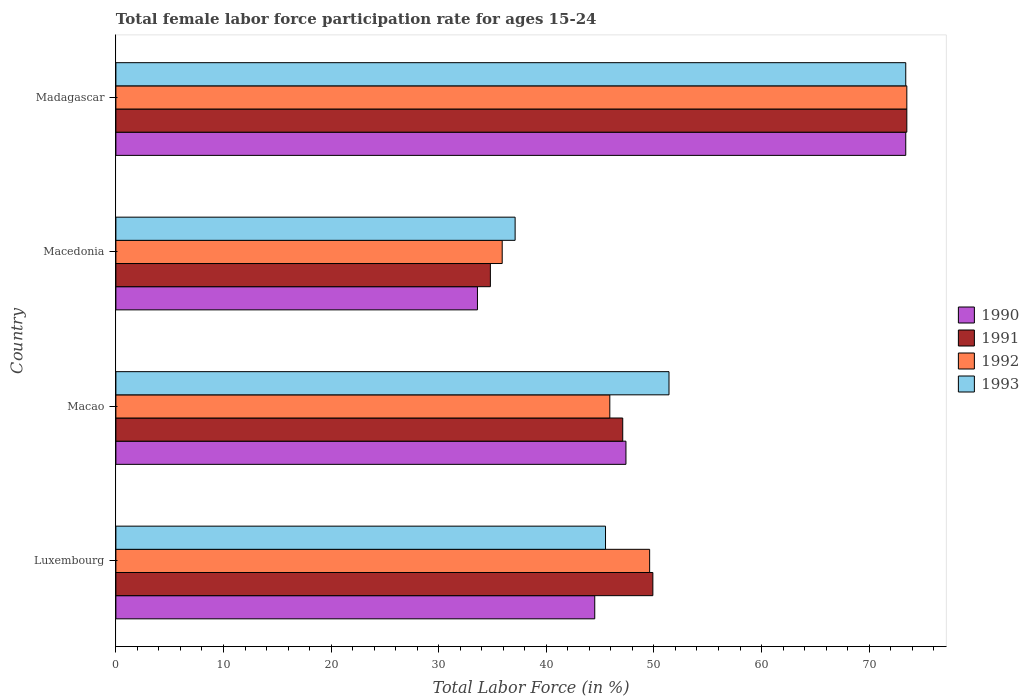How many different coloured bars are there?
Ensure brevity in your answer.  4. How many groups of bars are there?
Offer a terse response. 4. How many bars are there on the 1st tick from the top?
Your answer should be very brief. 4. What is the label of the 4th group of bars from the top?
Make the answer very short. Luxembourg. What is the female labor force participation rate in 1993 in Macedonia?
Your answer should be very brief. 37.1. Across all countries, what is the maximum female labor force participation rate in 1992?
Give a very brief answer. 73.5. Across all countries, what is the minimum female labor force participation rate in 1990?
Offer a terse response. 33.6. In which country was the female labor force participation rate in 1992 maximum?
Ensure brevity in your answer.  Madagascar. In which country was the female labor force participation rate in 1992 minimum?
Provide a succinct answer. Macedonia. What is the total female labor force participation rate in 1993 in the graph?
Your answer should be very brief. 207.4. What is the difference between the female labor force participation rate in 1993 in Macedonia and that in Madagascar?
Your answer should be compact. -36.3. What is the difference between the female labor force participation rate in 1993 in Macao and the female labor force participation rate in 1990 in Macedonia?
Ensure brevity in your answer.  17.8. What is the average female labor force participation rate in 1993 per country?
Offer a terse response. 51.85. What is the difference between the female labor force participation rate in 1991 and female labor force participation rate in 1990 in Madagascar?
Ensure brevity in your answer.  0.1. In how many countries, is the female labor force participation rate in 1993 greater than 14 %?
Offer a terse response. 4. What is the ratio of the female labor force participation rate in 1990 in Luxembourg to that in Macao?
Offer a terse response. 0.94. Is the female labor force participation rate in 1991 in Luxembourg less than that in Macao?
Provide a succinct answer. No. Is the difference between the female labor force participation rate in 1991 in Luxembourg and Madagascar greater than the difference between the female labor force participation rate in 1990 in Luxembourg and Madagascar?
Offer a very short reply. Yes. What is the difference between the highest and the second highest female labor force participation rate in 1992?
Ensure brevity in your answer.  23.9. What is the difference between the highest and the lowest female labor force participation rate in 1992?
Your answer should be compact. 37.6. In how many countries, is the female labor force participation rate in 1993 greater than the average female labor force participation rate in 1993 taken over all countries?
Provide a succinct answer. 1. Is the sum of the female labor force participation rate in 1990 in Macedonia and Madagascar greater than the maximum female labor force participation rate in 1991 across all countries?
Your response must be concise. Yes. Is it the case that in every country, the sum of the female labor force participation rate in 1990 and female labor force participation rate in 1991 is greater than the sum of female labor force participation rate in 1993 and female labor force participation rate in 1992?
Your response must be concise. No. What does the 4th bar from the top in Luxembourg represents?
Your response must be concise. 1990. What does the 1st bar from the bottom in Macedonia represents?
Your answer should be compact. 1990. How many bars are there?
Provide a succinct answer. 16. How many countries are there in the graph?
Your answer should be compact. 4. Does the graph contain any zero values?
Ensure brevity in your answer.  No. Does the graph contain grids?
Keep it short and to the point. No. What is the title of the graph?
Offer a very short reply. Total female labor force participation rate for ages 15-24. Does "1966" appear as one of the legend labels in the graph?
Keep it short and to the point. No. What is the label or title of the X-axis?
Your response must be concise. Total Labor Force (in %). What is the Total Labor Force (in %) in 1990 in Luxembourg?
Give a very brief answer. 44.5. What is the Total Labor Force (in %) of 1991 in Luxembourg?
Offer a very short reply. 49.9. What is the Total Labor Force (in %) in 1992 in Luxembourg?
Your answer should be compact. 49.6. What is the Total Labor Force (in %) of 1993 in Luxembourg?
Your response must be concise. 45.5. What is the Total Labor Force (in %) of 1990 in Macao?
Your response must be concise. 47.4. What is the Total Labor Force (in %) in 1991 in Macao?
Give a very brief answer. 47.1. What is the Total Labor Force (in %) of 1992 in Macao?
Offer a terse response. 45.9. What is the Total Labor Force (in %) of 1993 in Macao?
Make the answer very short. 51.4. What is the Total Labor Force (in %) of 1990 in Macedonia?
Keep it short and to the point. 33.6. What is the Total Labor Force (in %) in 1991 in Macedonia?
Make the answer very short. 34.8. What is the Total Labor Force (in %) in 1992 in Macedonia?
Keep it short and to the point. 35.9. What is the Total Labor Force (in %) in 1993 in Macedonia?
Your answer should be compact. 37.1. What is the Total Labor Force (in %) of 1990 in Madagascar?
Ensure brevity in your answer.  73.4. What is the Total Labor Force (in %) in 1991 in Madagascar?
Provide a succinct answer. 73.5. What is the Total Labor Force (in %) in 1992 in Madagascar?
Offer a very short reply. 73.5. What is the Total Labor Force (in %) in 1993 in Madagascar?
Your response must be concise. 73.4. Across all countries, what is the maximum Total Labor Force (in %) in 1990?
Your response must be concise. 73.4. Across all countries, what is the maximum Total Labor Force (in %) in 1991?
Offer a very short reply. 73.5. Across all countries, what is the maximum Total Labor Force (in %) of 1992?
Provide a succinct answer. 73.5. Across all countries, what is the maximum Total Labor Force (in %) in 1993?
Ensure brevity in your answer.  73.4. Across all countries, what is the minimum Total Labor Force (in %) of 1990?
Offer a very short reply. 33.6. Across all countries, what is the minimum Total Labor Force (in %) in 1991?
Your answer should be compact. 34.8. Across all countries, what is the minimum Total Labor Force (in %) in 1992?
Keep it short and to the point. 35.9. Across all countries, what is the minimum Total Labor Force (in %) of 1993?
Ensure brevity in your answer.  37.1. What is the total Total Labor Force (in %) in 1990 in the graph?
Give a very brief answer. 198.9. What is the total Total Labor Force (in %) of 1991 in the graph?
Your answer should be very brief. 205.3. What is the total Total Labor Force (in %) in 1992 in the graph?
Make the answer very short. 204.9. What is the total Total Labor Force (in %) of 1993 in the graph?
Your answer should be very brief. 207.4. What is the difference between the Total Labor Force (in %) of 1991 in Luxembourg and that in Macao?
Provide a short and direct response. 2.8. What is the difference between the Total Labor Force (in %) of 1992 in Luxembourg and that in Macao?
Provide a succinct answer. 3.7. What is the difference between the Total Labor Force (in %) of 1993 in Luxembourg and that in Macao?
Give a very brief answer. -5.9. What is the difference between the Total Labor Force (in %) of 1991 in Luxembourg and that in Macedonia?
Make the answer very short. 15.1. What is the difference between the Total Labor Force (in %) in 1992 in Luxembourg and that in Macedonia?
Give a very brief answer. 13.7. What is the difference between the Total Labor Force (in %) of 1993 in Luxembourg and that in Macedonia?
Keep it short and to the point. 8.4. What is the difference between the Total Labor Force (in %) of 1990 in Luxembourg and that in Madagascar?
Your response must be concise. -28.9. What is the difference between the Total Labor Force (in %) in 1991 in Luxembourg and that in Madagascar?
Offer a very short reply. -23.6. What is the difference between the Total Labor Force (in %) in 1992 in Luxembourg and that in Madagascar?
Provide a short and direct response. -23.9. What is the difference between the Total Labor Force (in %) of 1993 in Luxembourg and that in Madagascar?
Your answer should be compact. -27.9. What is the difference between the Total Labor Force (in %) in 1990 in Macao and that in Macedonia?
Your answer should be very brief. 13.8. What is the difference between the Total Labor Force (in %) in 1992 in Macao and that in Macedonia?
Your response must be concise. 10. What is the difference between the Total Labor Force (in %) of 1990 in Macao and that in Madagascar?
Ensure brevity in your answer.  -26. What is the difference between the Total Labor Force (in %) of 1991 in Macao and that in Madagascar?
Give a very brief answer. -26.4. What is the difference between the Total Labor Force (in %) in 1992 in Macao and that in Madagascar?
Your answer should be compact. -27.6. What is the difference between the Total Labor Force (in %) in 1990 in Macedonia and that in Madagascar?
Keep it short and to the point. -39.8. What is the difference between the Total Labor Force (in %) of 1991 in Macedonia and that in Madagascar?
Ensure brevity in your answer.  -38.7. What is the difference between the Total Labor Force (in %) of 1992 in Macedonia and that in Madagascar?
Make the answer very short. -37.6. What is the difference between the Total Labor Force (in %) of 1993 in Macedonia and that in Madagascar?
Provide a succinct answer. -36.3. What is the difference between the Total Labor Force (in %) in 1990 in Luxembourg and the Total Labor Force (in %) in 1991 in Macao?
Your answer should be compact. -2.6. What is the difference between the Total Labor Force (in %) of 1990 in Luxembourg and the Total Labor Force (in %) of 1993 in Macao?
Make the answer very short. -6.9. What is the difference between the Total Labor Force (in %) in 1992 in Luxembourg and the Total Labor Force (in %) in 1993 in Macao?
Keep it short and to the point. -1.8. What is the difference between the Total Labor Force (in %) of 1990 in Luxembourg and the Total Labor Force (in %) of 1992 in Macedonia?
Keep it short and to the point. 8.6. What is the difference between the Total Labor Force (in %) in 1990 in Luxembourg and the Total Labor Force (in %) in 1993 in Macedonia?
Offer a very short reply. 7.4. What is the difference between the Total Labor Force (in %) in 1992 in Luxembourg and the Total Labor Force (in %) in 1993 in Macedonia?
Make the answer very short. 12.5. What is the difference between the Total Labor Force (in %) of 1990 in Luxembourg and the Total Labor Force (in %) of 1993 in Madagascar?
Make the answer very short. -28.9. What is the difference between the Total Labor Force (in %) of 1991 in Luxembourg and the Total Labor Force (in %) of 1992 in Madagascar?
Offer a terse response. -23.6. What is the difference between the Total Labor Force (in %) of 1991 in Luxembourg and the Total Labor Force (in %) of 1993 in Madagascar?
Offer a terse response. -23.5. What is the difference between the Total Labor Force (in %) of 1992 in Luxembourg and the Total Labor Force (in %) of 1993 in Madagascar?
Your answer should be compact. -23.8. What is the difference between the Total Labor Force (in %) of 1990 in Macao and the Total Labor Force (in %) of 1992 in Macedonia?
Provide a short and direct response. 11.5. What is the difference between the Total Labor Force (in %) in 1990 in Macao and the Total Labor Force (in %) in 1993 in Macedonia?
Your answer should be compact. 10.3. What is the difference between the Total Labor Force (in %) of 1991 in Macao and the Total Labor Force (in %) of 1992 in Macedonia?
Keep it short and to the point. 11.2. What is the difference between the Total Labor Force (in %) in 1992 in Macao and the Total Labor Force (in %) in 1993 in Macedonia?
Give a very brief answer. 8.8. What is the difference between the Total Labor Force (in %) of 1990 in Macao and the Total Labor Force (in %) of 1991 in Madagascar?
Provide a short and direct response. -26.1. What is the difference between the Total Labor Force (in %) of 1990 in Macao and the Total Labor Force (in %) of 1992 in Madagascar?
Provide a short and direct response. -26.1. What is the difference between the Total Labor Force (in %) in 1990 in Macao and the Total Labor Force (in %) in 1993 in Madagascar?
Offer a terse response. -26. What is the difference between the Total Labor Force (in %) in 1991 in Macao and the Total Labor Force (in %) in 1992 in Madagascar?
Your answer should be compact. -26.4. What is the difference between the Total Labor Force (in %) in 1991 in Macao and the Total Labor Force (in %) in 1993 in Madagascar?
Offer a very short reply. -26.3. What is the difference between the Total Labor Force (in %) in 1992 in Macao and the Total Labor Force (in %) in 1993 in Madagascar?
Keep it short and to the point. -27.5. What is the difference between the Total Labor Force (in %) in 1990 in Macedonia and the Total Labor Force (in %) in 1991 in Madagascar?
Your answer should be compact. -39.9. What is the difference between the Total Labor Force (in %) in 1990 in Macedonia and the Total Labor Force (in %) in 1992 in Madagascar?
Your answer should be very brief. -39.9. What is the difference between the Total Labor Force (in %) of 1990 in Macedonia and the Total Labor Force (in %) of 1993 in Madagascar?
Give a very brief answer. -39.8. What is the difference between the Total Labor Force (in %) of 1991 in Macedonia and the Total Labor Force (in %) of 1992 in Madagascar?
Your answer should be compact. -38.7. What is the difference between the Total Labor Force (in %) in 1991 in Macedonia and the Total Labor Force (in %) in 1993 in Madagascar?
Keep it short and to the point. -38.6. What is the difference between the Total Labor Force (in %) in 1992 in Macedonia and the Total Labor Force (in %) in 1993 in Madagascar?
Offer a terse response. -37.5. What is the average Total Labor Force (in %) in 1990 per country?
Your answer should be very brief. 49.73. What is the average Total Labor Force (in %) of 1991 per country?
Provide a succinct answer. 51.33. What is the average Total Labor Force (in %) of 1992 per country?
Provide a short and direct response. 51.23. What is the average Total Labor Force (in %) of 1993 per country?
Offer a very short reply. 51.85. What is the difference between the Total Labor Force (in %) of 1990 and Total Labor Force (in %) of 1992 in Luxembourg?
Make the answer very short. -5.1. What is the difference between the Total Labor Force (in %) of 1990 and Total Labor Force (in %) of 1993 in Luxembourg?
Offer a terse response. -1. What is the difference between the Total Labor Force (in %) in 1991 and Total Labor Force (in %) in 1992 in Luxembourg?
Make the answer very short. 0.3. What is the difference between the Total Labor Force (in %) in 1990 and Total Labor Force (in %) in 1992 in Macao?
Your response must be concise. 1.5. What is the difference between the Total Labor Force (in %) of 1991 and Total Labor Force (in %) of 1992 in Macao?
Keep it short and to the point. 1.2. What is the difference between the Total Labor Force (in %) in 1991 and Total Labor Force (in %) in 1993 in Macao?
Give a very brief answer. -4.3. What is the difference between the Total Labor Force (in %) in 1990 and Total Labor Force (in %) in 1991 in Macedonia?
Give a very brief answer. -1.2. What is the difference between the Total Labor Force (in %) in 1990 and Total Labor Force (in %) in 1993 in Macedonia?
Offer a terse response. -3.5. What is the difference between the Total Labor Force (in %) of 1991 and Total Labor Force (in %) of 1992 in Macedonia?
Ensure brevity in your answer.  -1.1. What is the difference between the Total Labor Force (in %) in 1990 and Total Labor Force (in %) in 1993 in Madagascar?
Keep it short and to the point. 0. What is the difference between the Total Labor Force (in %) of 1991 and Total Labor Force (in %) of 1992 in Madagascar?
Ensure brevity in your answer.  0. What is the difference between the Total Labor Force (in %) of 1992 and Total Labor Force (in %) of 1993 in Madagascar?
Offer a terse response. 0.1. What is the ratio of the Total Labor Force (in %) of 1990 in Luxembourg to that in Macao?
Give a very brief answer. 0.94. What is the ratio of the Total Labor Force (in %) of 1991 in Luxembourg to that in Macao?
Provide a succinct answer. 1.06. What is the ratio of the Total Labor Force (in %) of 1992 in Luxembourg to that in Macao?
Ensure brevity in your answer.  1.08. What is the ratio of the Total Labor Force (in %) in 1993 in Luxembourg to that in Macao?
Offer a terse response. 0.89. What is the ratio of the Total Labor Force (in %) of 1990 in Luxembourg to that in Macedonia?
Ensure brevity in your answer.  1.32. What is the ratio of the Total Labor Force (in %) in 1991 in Luxembourg to that in Macedonia?
Keep it short and to the point. 1.43. What is the ratio of the Total Labor Force (in %) of 1992 in Luxembourg to that in Macedonia?
Your answer should be compact. 1.38. What is the ratio of the Total Labor Force (in %) in 1993 in Luxembourg to that in Macedonia?
Give a very brief answer. 1.23. What is the ratio of the Total Labor Force (in %) of 1990 in Luxembourg to that in Madagascar?
Provide a short and direct response. 0.61. What is the ratio of the Total Labor Force (in %) in 1991 in Luxembourg to that in Madagascar?
Keep it short and to the point. 0.68. What is the ratio of the Total Labor Force (in %) in 1992 in Luxembourg to that in Madagascar?
Your answer should be compact. 0.67. What is the ratio of the Total Labor Force (in %) in 1993 in Luxembourg to that in Madagascar?
Make the answer very short. 0.62. What is the ratio of the Total Labor Force (in %) in 1990 in Macao to that in Macedonia?
Make the answer very short. 1.41. What is the ratio of the Total Labor Force (in %) of 1991 in Macao to that in Macedonia?
Provide a short and direct response. 1.35. What is the ratio of the Total Labor Force (in %) in 1992 in Macao to that in Macedonia?
Your answer should be very brief. 1.28. What is the ratio of the Total Labor Force (in %) in 1993 in Macao to that in Macedonia?
Give a very brief answer. 1.39. What is the ratio of the Total Labor Force (in %) in 1990 in Macao to that in Madagascar?
Your response must be concise. 0.65. What is the ratio of the Total Labor Force (in %) in 1991 in Macao to that in Madagascar?
Ensure brevity in your answer.  0.64. What is the ratio of the Total Labor Force (in %) in 1992 in Macao to that in Madagascar?
Make the answer very short. 0.62. What is the ratio of the Total Labor Force (in %) in 1993 in Macao to that in Madagascar?
Your response must be concise. 0.7. What is the ratio of the Total Labor Force (in %) of 1990 in Macedonia to that in Madagascar?
Keep it short and to the point. 0.46. What is the ratio of the Total Labor Force (in %) of 1991 in Macedonia to that in Madagascar?
Provide a succinct answer. 0.47. What is the ratio of the Total Labor Force (in %) of 1992 in Macedonia to that in Madagascar?
Your response must be concise. 0.49. What is the ratio of the Total Labor Force (in %) in 1993 in Macedonia to that in Madagascar?
Offer a terse response. 0.51. What is the difference between the highest and the second highest Total Labor Force (in %) in 1990?
Your answer should be compact. 26. What is the difference between the highest and the second highest Total Labor Force (in %) of 1991?
Make the answer very short. 23.6. What is the difference between the highest and the second highest Total Labor Force (in %) in 1992?
Your answer should be compact. 23.9. What is the difference between the highest and the second highest Total Labor Force (in %) of 1993?
Offer a very short reply. 22. What is the difference between the highest and the lowest Total Labor Force (in %) of 1990?
Your response must be concise. 39.8. What is the difference between the highest and the lowest Total Labor Force (in %) of 1991?
Offer a very short reply. 38.7. What is the difference between the highest and the lowest Total Labor Force (in %) in 1992?
Provide a succinct answer. 37.6. What is the difference between the highest and the lowest Total Labor Force (in %) in 1993?
Keep it short and to the point. 36.3. 